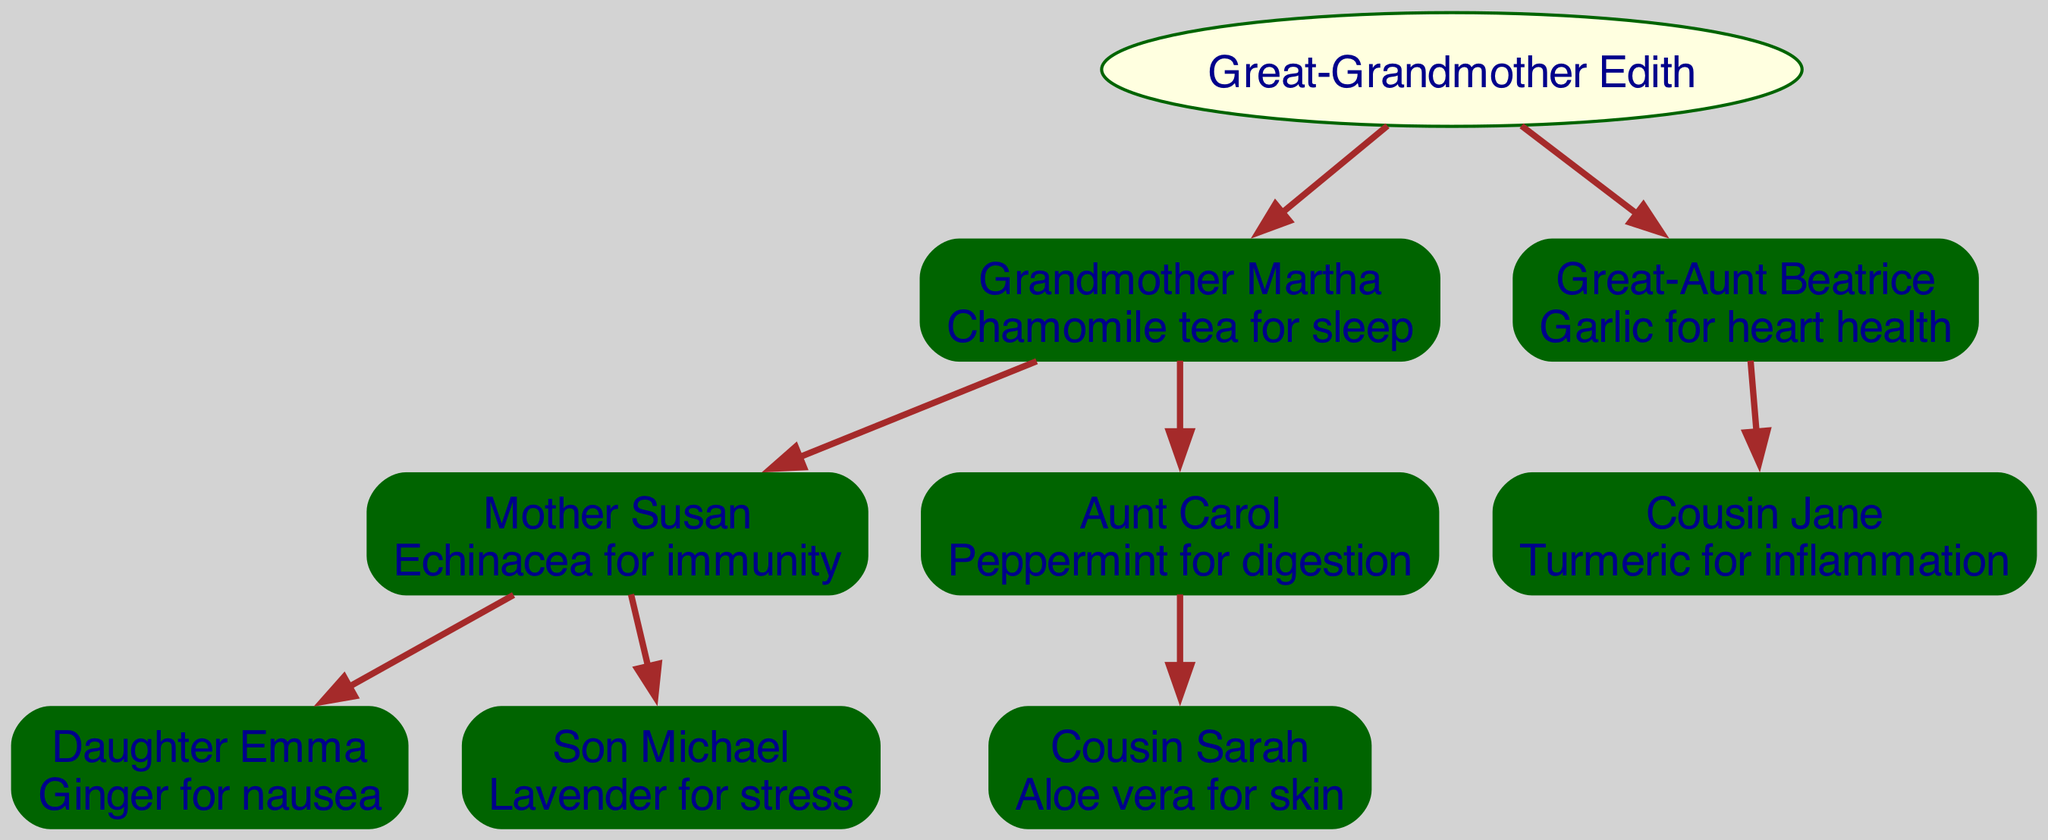What remedy does Grandmother Martha provide? Grandmother Martha's remedy is specifically listed under her node in the family tree. It states "Chamomile tea for sleep," which can be directly read from the diagram.
Answer: Chamomile tea for sleep Who is Daughter Emma's mother? To find Daughter Emma's mother, we need to follow the lineage from Emma upwards. Emma is under Mother Susan's node, which establishes that Susan is her mother.
Answer: Mother Susan How many children does Grandmother Martha have? By examining Grandmother Martha's node, we can count the number of children she has listed as her direct descendants. She has two children: Mother Susan and Aunt Carol.
Answer: 2 What remedy does Great-Aunt Beatrice use? Great-Aunt Beatrice's remedy is noted in her specific node within the diagram. The remedy stated there is "Garlic for heart health."
Answer: Garlic for heart health Which remedy is used by Cousin Jane? Cousin Jane's remedy is clearly mentioned in her node. In the family tree, it states that she uses "Turmeric for inflammation."
Answer: Turmeric for inflammation How many generations are represented in this family tree? The family tree shows multiple generations: Great-Grandmother Edith is the root, followed by two generations underneath her (Grandmother Martha and Great-Aunt Beatrice), and another generation below Martha (Mother Susan and Aunt Carol) and their children. This indicates four generations in total.
Answer: 4 What relationship does Cousin Sarah have with Grandmother Martha? To find the relationship, we check Cousin Sarah's position in the tree. Sarah is the child of Aunt Carol, who is a daughter of Grandmother Martha. Therefore, Cousin Sarah is the granddaughter of Grandmother Martha.
Answer: Granddaughter Which herbal remedy is associated with Son Michael? Son Michael's remedy is explicitly stated in his node in the family tree. It lists “Lavender for stress.” Hence, we simply look at Michael's node to find this information.
Answer: Lavender for stress What is the remedy shared by Great-Grandmother Edith and Great-Aunt Beatrice? By examining the remedies assigned to both Great-Grandmother Edith and Great-Aunt Beatrice, we find that Edith's remedy is not mentioned, while Great-Aunt Beatrice uses "Garlic for heart health." Therefore, they do not share any common remedies.
Answer: None 